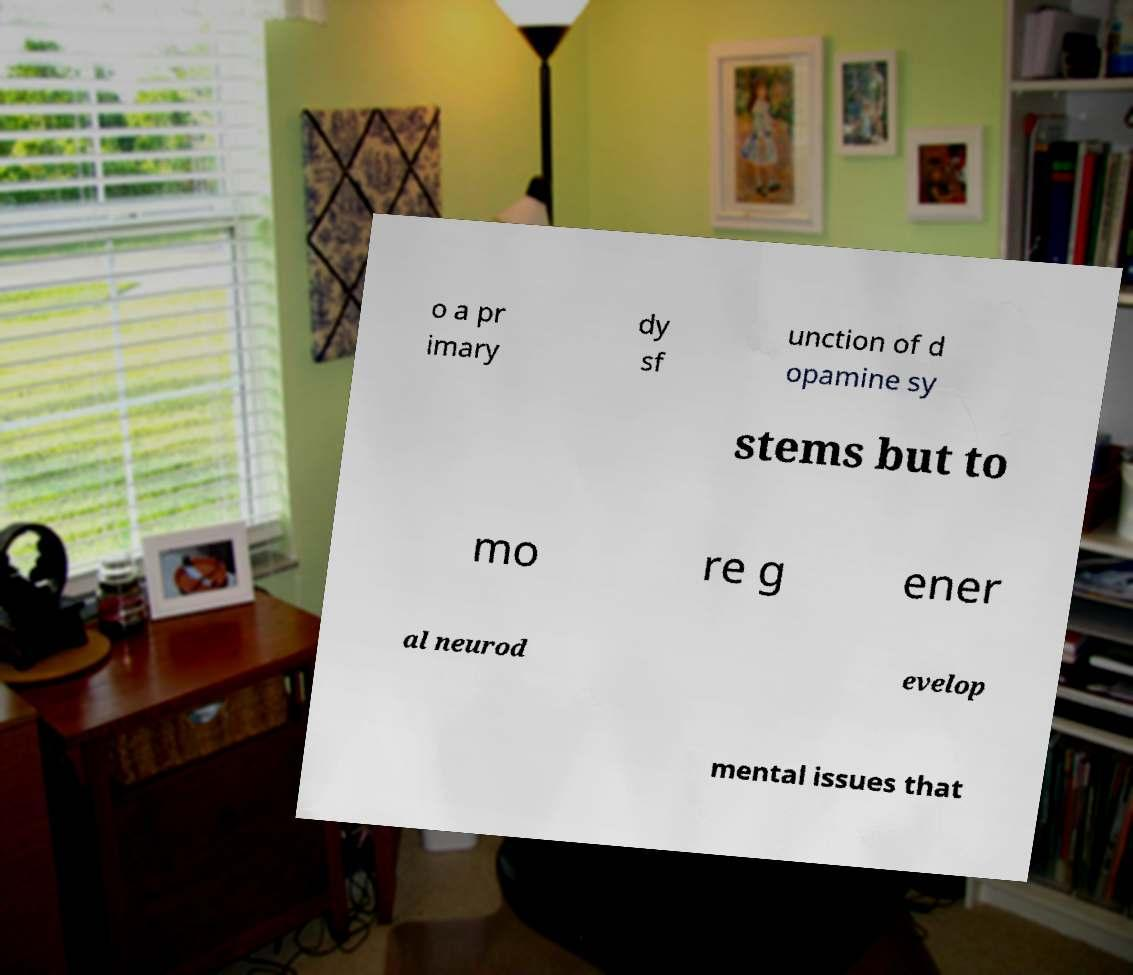What messages or text are displayed in this image? I need them in a readable, typed format. o a pr imary dy sf unction of d opamine sy stems but to mo re g ener al neurod evelop mental issues that 